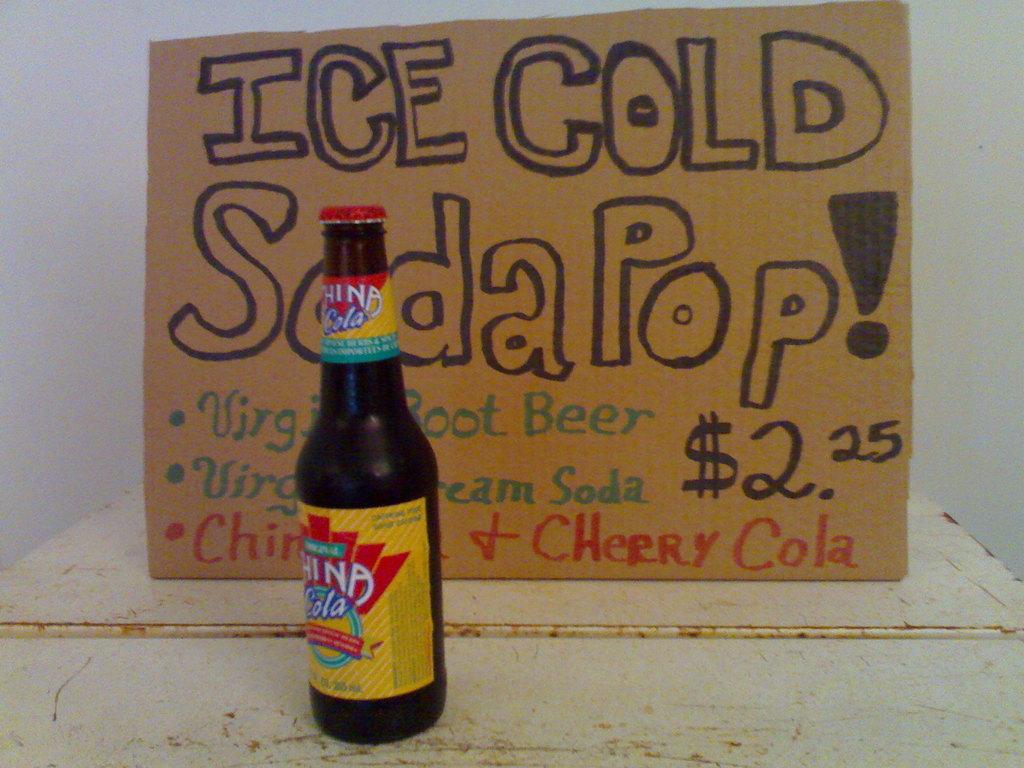What is ice cold?
Ensure brevity in your answer.  Soda pop. 